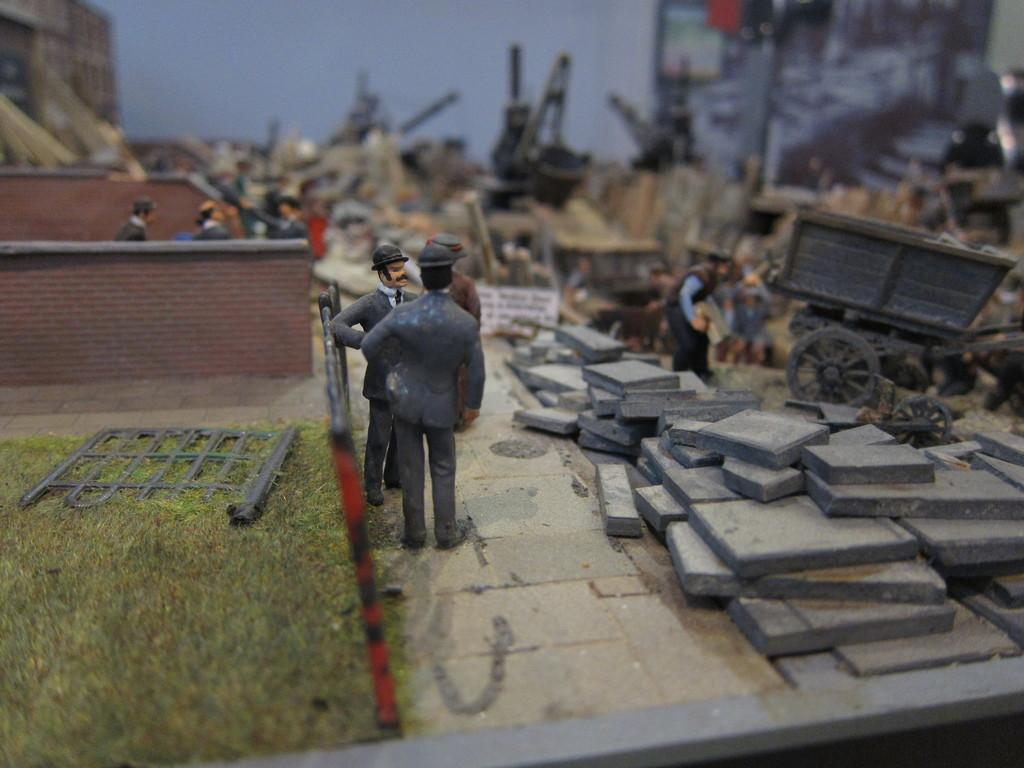How many people are in the image? There are persons in the image, but the exact number cannot be determined from the provided facts. What type of vehicle is present in the image? There is a cart vehicle in the image. What structures can be seen in the image? There is a wall and a fence in the image. What type of vegetation is visible in the image? There is grass in the image. What type of nail is being used to fix the sink in the image? There is no sink or nail present in the image. What type of drink is being served from the cart vehicle in the image? There is no drink or cart vehicle serving drinks in the image. 